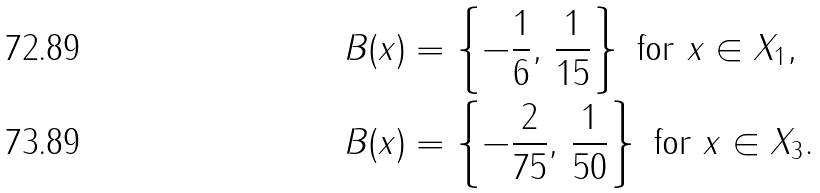Convert formula to latex. <formula><loc_0><loc_0><loc_500><loc_500>& B ( x ) = \left \{ - \frac { 1 } { 6 } , \, \frac { 1 } { 1 5 } \right \} \text { for } x \in X _ { 1 } , \\ & B ( x ) = \left \{ - \frac { 2 } { 7 5 } , \, \frac { 1 } { 5 0 } \right \} \text { for } x \in X _ { 3 } .</formula> 